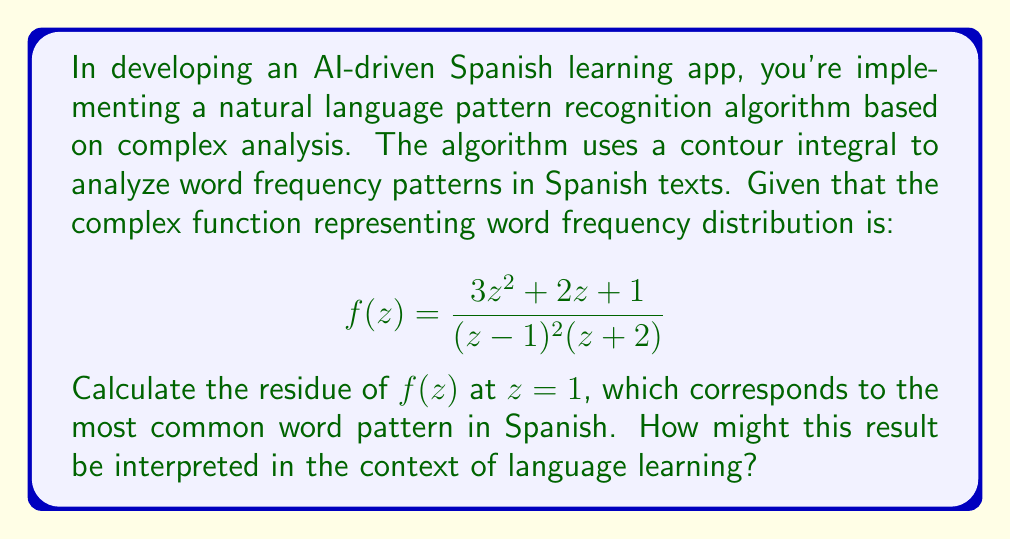What is the answer to this math problem? To solve this problem, we'll use the residue theorem from complex analysis. The steps are as follows:

1) First, we identify that $z=1$ is a pole of order 2 for $f(z)$. This is because $(z-1)^2$ appears in the denominator.

2) For a pole of order 2, we use the formula:

   $$\text{Res}(f,1) = \lim_{z \to 1} \frac{d}{dz}\left[(z-1)^2f(z)\right]$$

3) Let's define $g(z) = (z-1)^2f(z)$:

   $$g(z) = \frac{3z^2 + 2z + 1}{z+2}$$

4) Now we need to find $g'(z)$:

   $$g'(z) = \frac{(6z+2)(z+2) - (3z^2 + 2z + 1)}{(z+2)^2}$$

5) Simplify:

   $$g'(z) = \frac{6z^2 + 12z + 4z + 8 - 3z^2 - 2z - 1}{(z+2)^2} = \frac{3z^2 + 14z + 7}{(z+2)^2}$$

6) Now we evaluate this at $z=1$:

   $$\text{Res}(f,1) = g'(1) = \frac{3(1)^2 + 14(1) + 7}{(1+2)^2} = \frac{24}{9} = \frac{8}{3}$$

Interpretation: In the context of language learning, this residue value could represent the relative importance or frequency of the most common word pattern in Spanish. A higher residue value might indicate a more dominant pattern, which could be prioritized in the learning algorithm. This information could be used to structure lessons, create exercises, or fine-tune the app's natural language processing capabilities for more effective Spanish language instruction.
Answer: The residue of $f(z)$ at $z=1$ is $\frac{8}{3}$. 